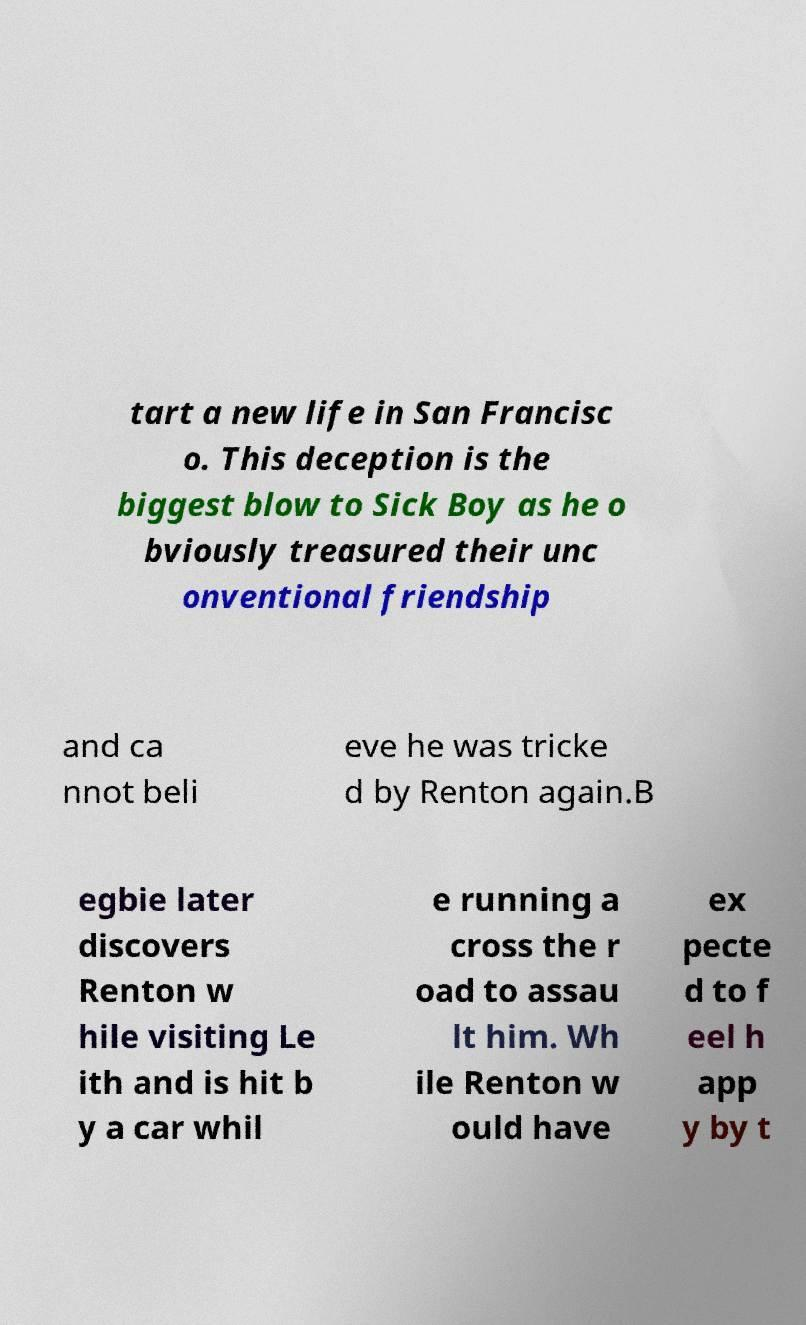Could you assist in decoding the text presented in this image and type it out clearly? tart a new life in San Francisc o. This deception is the biggest blow to Sick Boy as he o bviously treasured their unc onventional friendship and ca nnot beli eve he was tricke d by Renton again.B egbie later discovers Renton w hile visiting Le ith and is hit b y a car whil e running a cross the r oad to assau lt him. Wh ile Renton w ould have ex pecte d to f eel h app y by t 